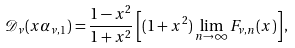<formula> <loc_0><loc_0><loc_500><loc_500>\mathcal { D } _ { \nu } ( x \alpha _ { \nu , 1 } ) = \frac { 1 - x ^ { 2 } } { 1 + x ^ { 2 } } \left [ ( 1 + x ^ { 2 } ) \lim _ { n \rightarrow \infty } F _ { \nu , n } ( x ) \right ] ,</formula> 